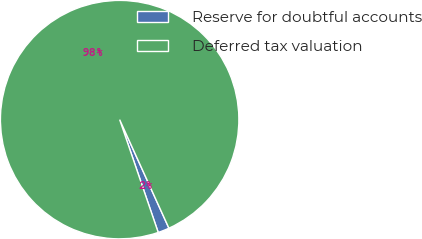<chart> <loc_0><loc_0><loc_500><loc_500><pie_chart><fcel>Reserve for doubtful accounts<fcel>Deferred tax valuation<nl><fcel>1.54%<fcel>98.46%<nl></chart> 